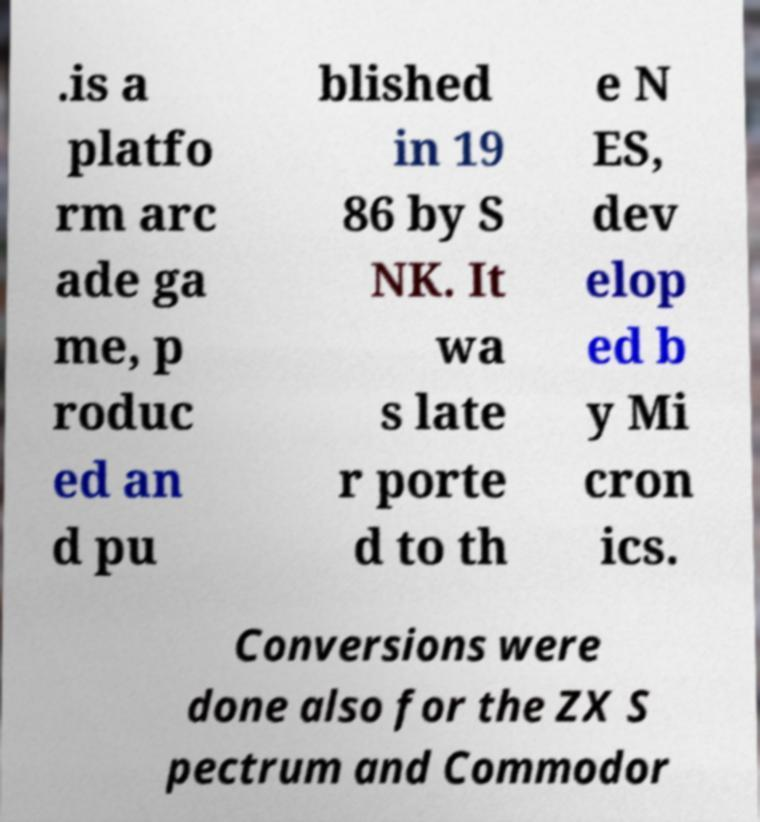Please read and relay the text visible in this image. What does it say? .is a platfo rm arc ade ga me, p roduc ed an d pu blished in 19 86 by S NK. It wa s late r porte d to th e N ES, dev elop ed b y Mi cron ics. Conversions were done also for the ZX S pectrum and Commodor 